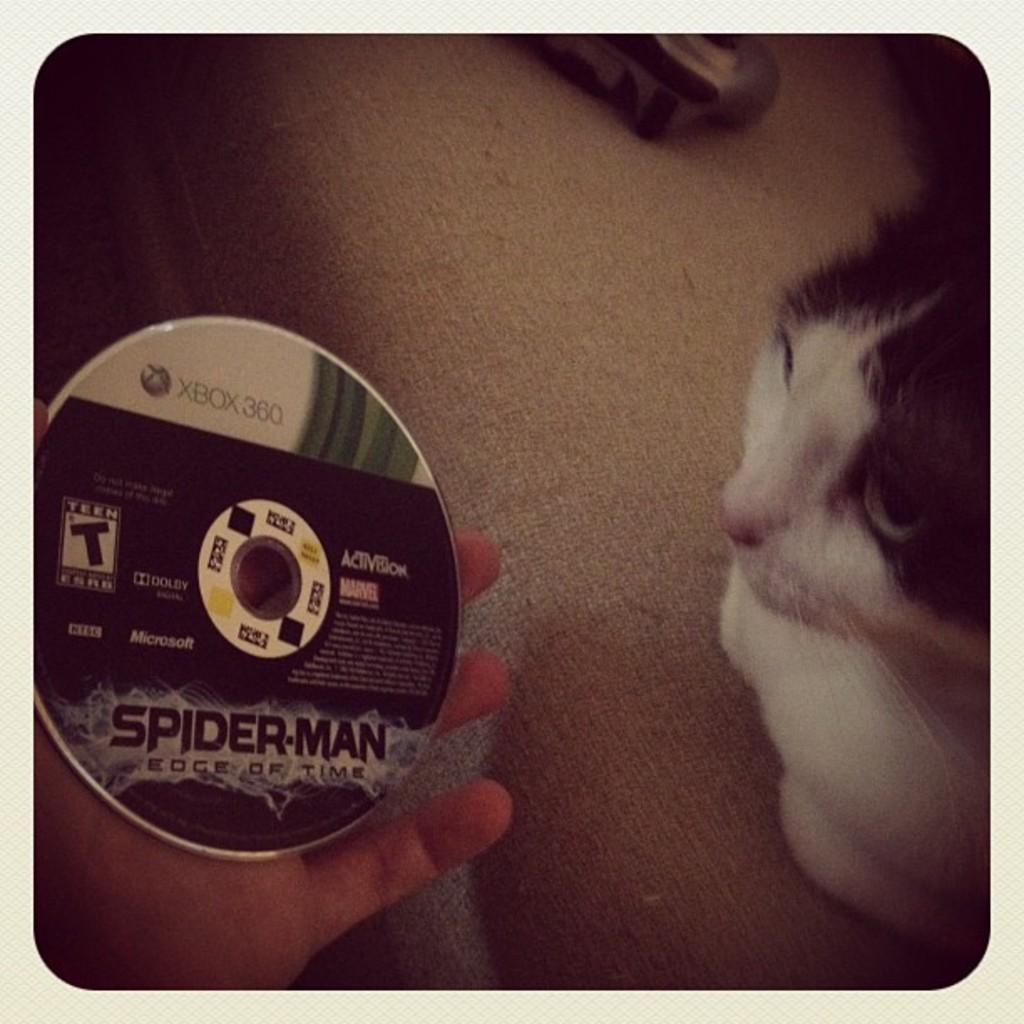Can you describe this image briefly? This is an edited picture. In this image there is a person holding the disk and there is text on the disc and there is a cat sitting. At the back there is an object. At the bottom there is a floor. 